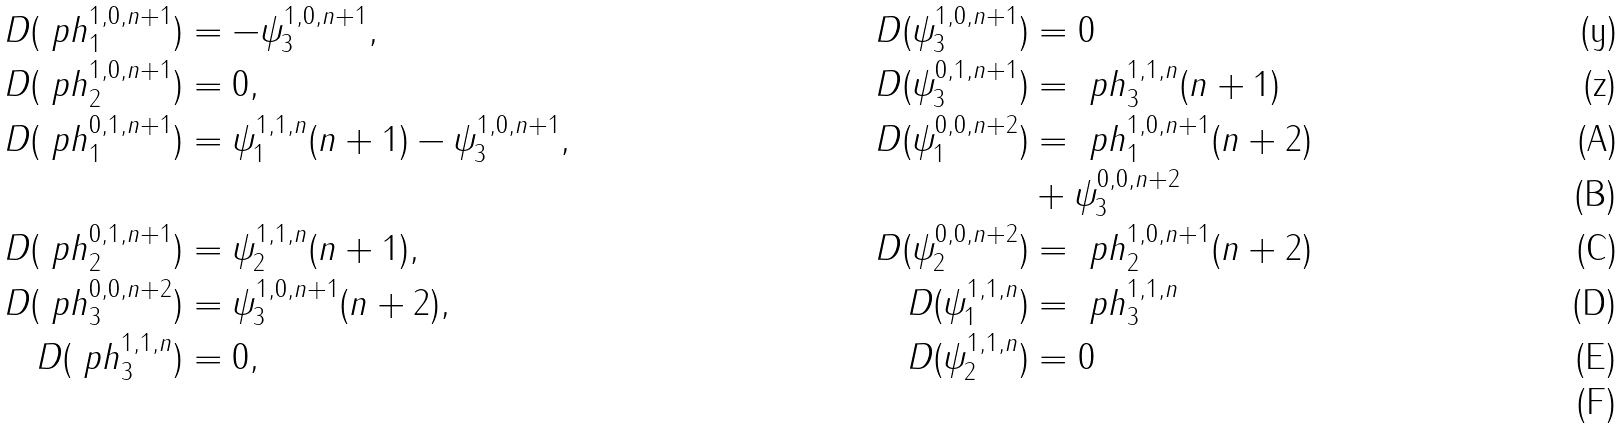Convert formula to latex. <formula><loc_0><loc_0><loc_500><loc_500>D ( \ p h ^ { 1 , 0 , n + 1 } _ { 1 } ) & = - \psi ^ { 1 , 0 , n + 1 } _ { 3 } , & D ( \psi ^ { 1 , 0 , n + 1 } _ { 3 } ) & = 0 \\ D ( \ p h ^ { 1 , 0 , n + 1 } _ { 2 } ) & = 0 , & D ( \psi ^ { 0 , 1 , n + 1 } _ { 3 } ) & = \ p h ^ { 1 , 1 , n } _ { 3 } ( n + 1 ) \\ D ( \ p h ^ { 0 , 1 , n + 1 } _ { 1 } ) & = \psi ^ { 1 , 1 , n } _ { 1 } ( n + 1 ) - \psi ^ { 1 , 0 , n + 1 } _ { 3 } , & D ( \psi ^ { 0 , 0 , n + 2 } _ { 1 } ) & = \ p h ^ { 1 , 0 , n + 1 } _ { 1 } ( n + 2 ) \\ & & & + \psi ^ { 0 , 0 , n + 2 } _ { 3 } \\ D ( \ p h ^ { 0 , 1 , n + 1 } _ { 2 } ) & = \psi ^ { 1 , 1 , n } _ { 2 } ( n + 1 ) , & D ( \psi ^ { 0 , 0 , n + 2 } _ { 2 } ) & = \ p h ^ { 1 , 0 , n + 1 } _ { 2 } ( n + 2 ) \\ D ( \ p h ^ { 0 , 0 , n + 2 } _ { 3 } ) & = \psi ^ { 1 , 0 , n + 1 } _ { 3 } ( n + 2 ) , & D ( \psi ^ { 1 , 1 , n } _ { 1 } ) & = \ p h ^ { 1 , 1 , n } _ { 3 } \\ D ( \ p h ^ { 1 , 1 , n } _ { 3 } ) & = 0 , & D ( \psi ^ { 1 , 1 , n } _ { 2 } ) & = 0 \\</formula> 